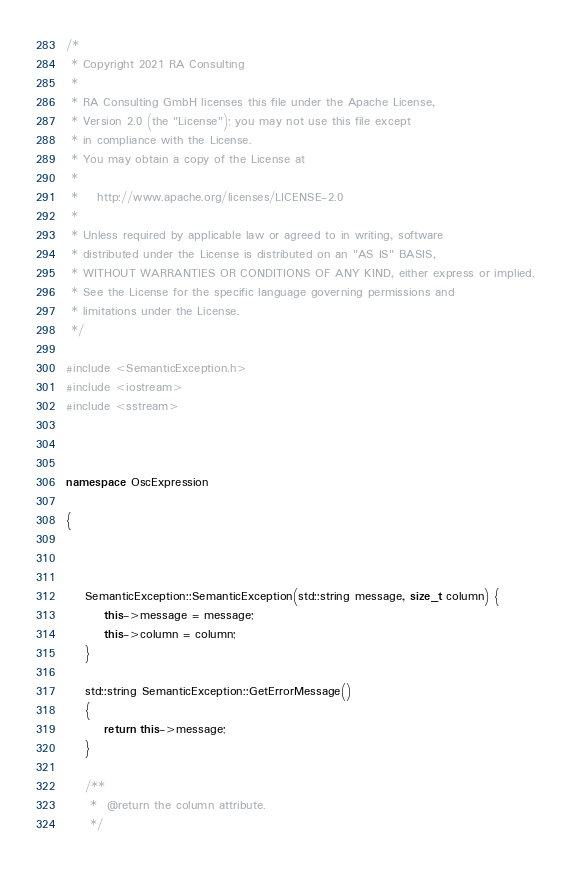<code> <loc_0><loc_0><loc_500><loc_500><_C++_>/*
 * Copyright 2021 RA Consulting
 *
 * RA Consulting GmbH licenses this file under the Apache License,
 * Version 2.0 (the "License"); you may not use this file except
 * in compliance with the License.
 * You may obtain a copy of the License at
 *
 *    http://www.apache.org/licenses/LICENSE-2.0
 *
 * Unless required by applicable law or agreed to in writing, software
 * distributed under the License is distributed on an "AS IS" BASIS,
 * WITHOUT WARRANTIES OR CONDITIONS OF ANY KIND, either express or implied.
 * See the License for the specific language governing permissions and
 * limitations under the License.
 */

#include <SemanticException.h>
#include <iostream>
#include <sstream>



namespace OscExpression

{

	

	SemanticException::SemanticException(std::string message, size_t column) {
		this->message = message;
		this->column = column;
	}

	std::string SemanticException::GetErrorMessage()
	{
		return this->message;
	}

	/**
	 *  @return the column attribute.
	 */</code> 